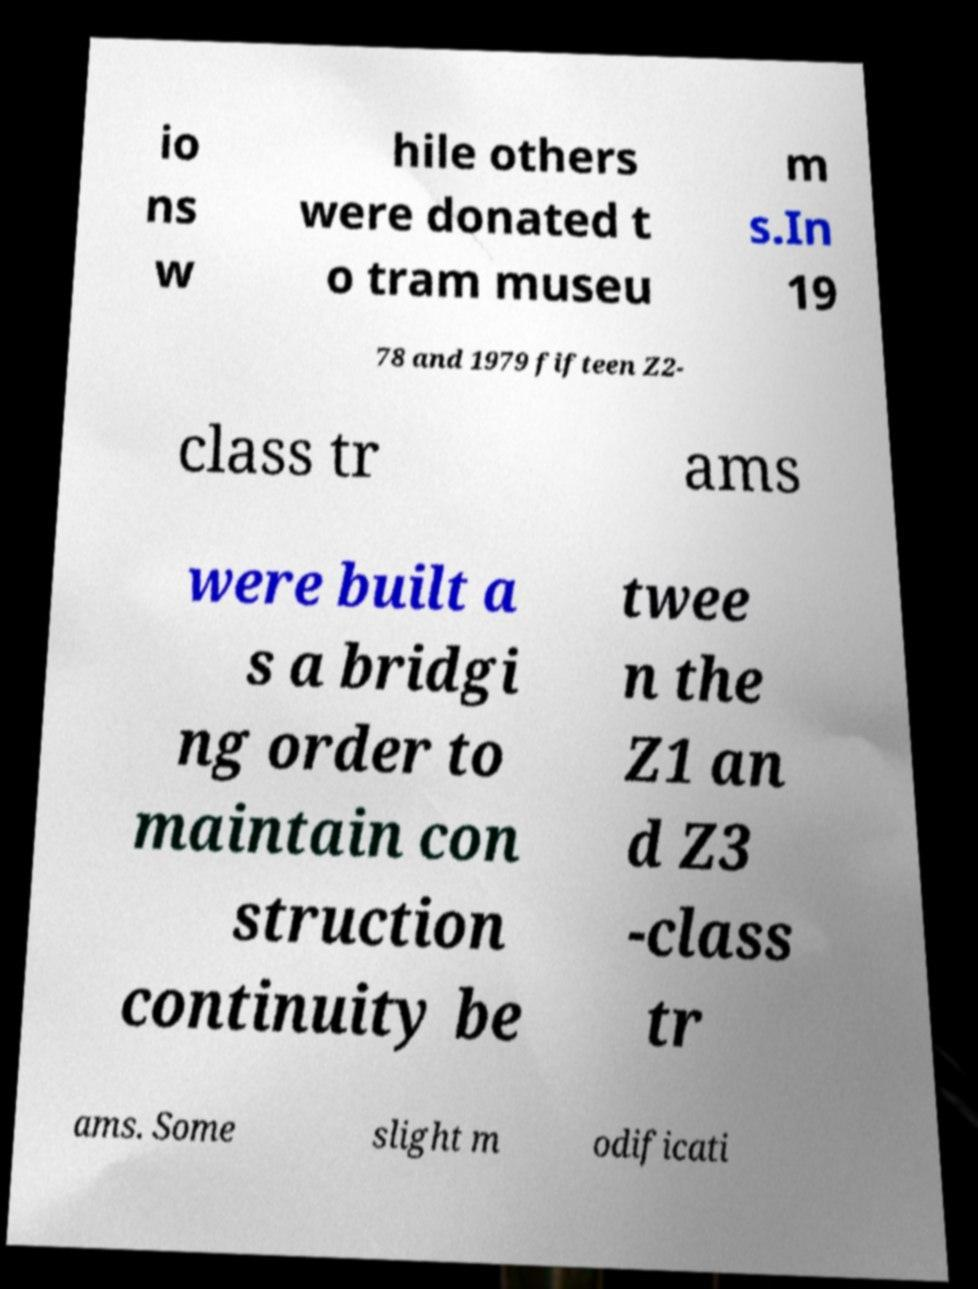Could you extract and type out the text from this image? io ns w hile others were donated t o tram museu m s.In 19 78 and 1979 fifteen Z2- class tr ams were built a s a bridgi ng order to maintain con struction continuity be twee n the Z1 an d Z3 -class tr ams. Some slight m odificati 